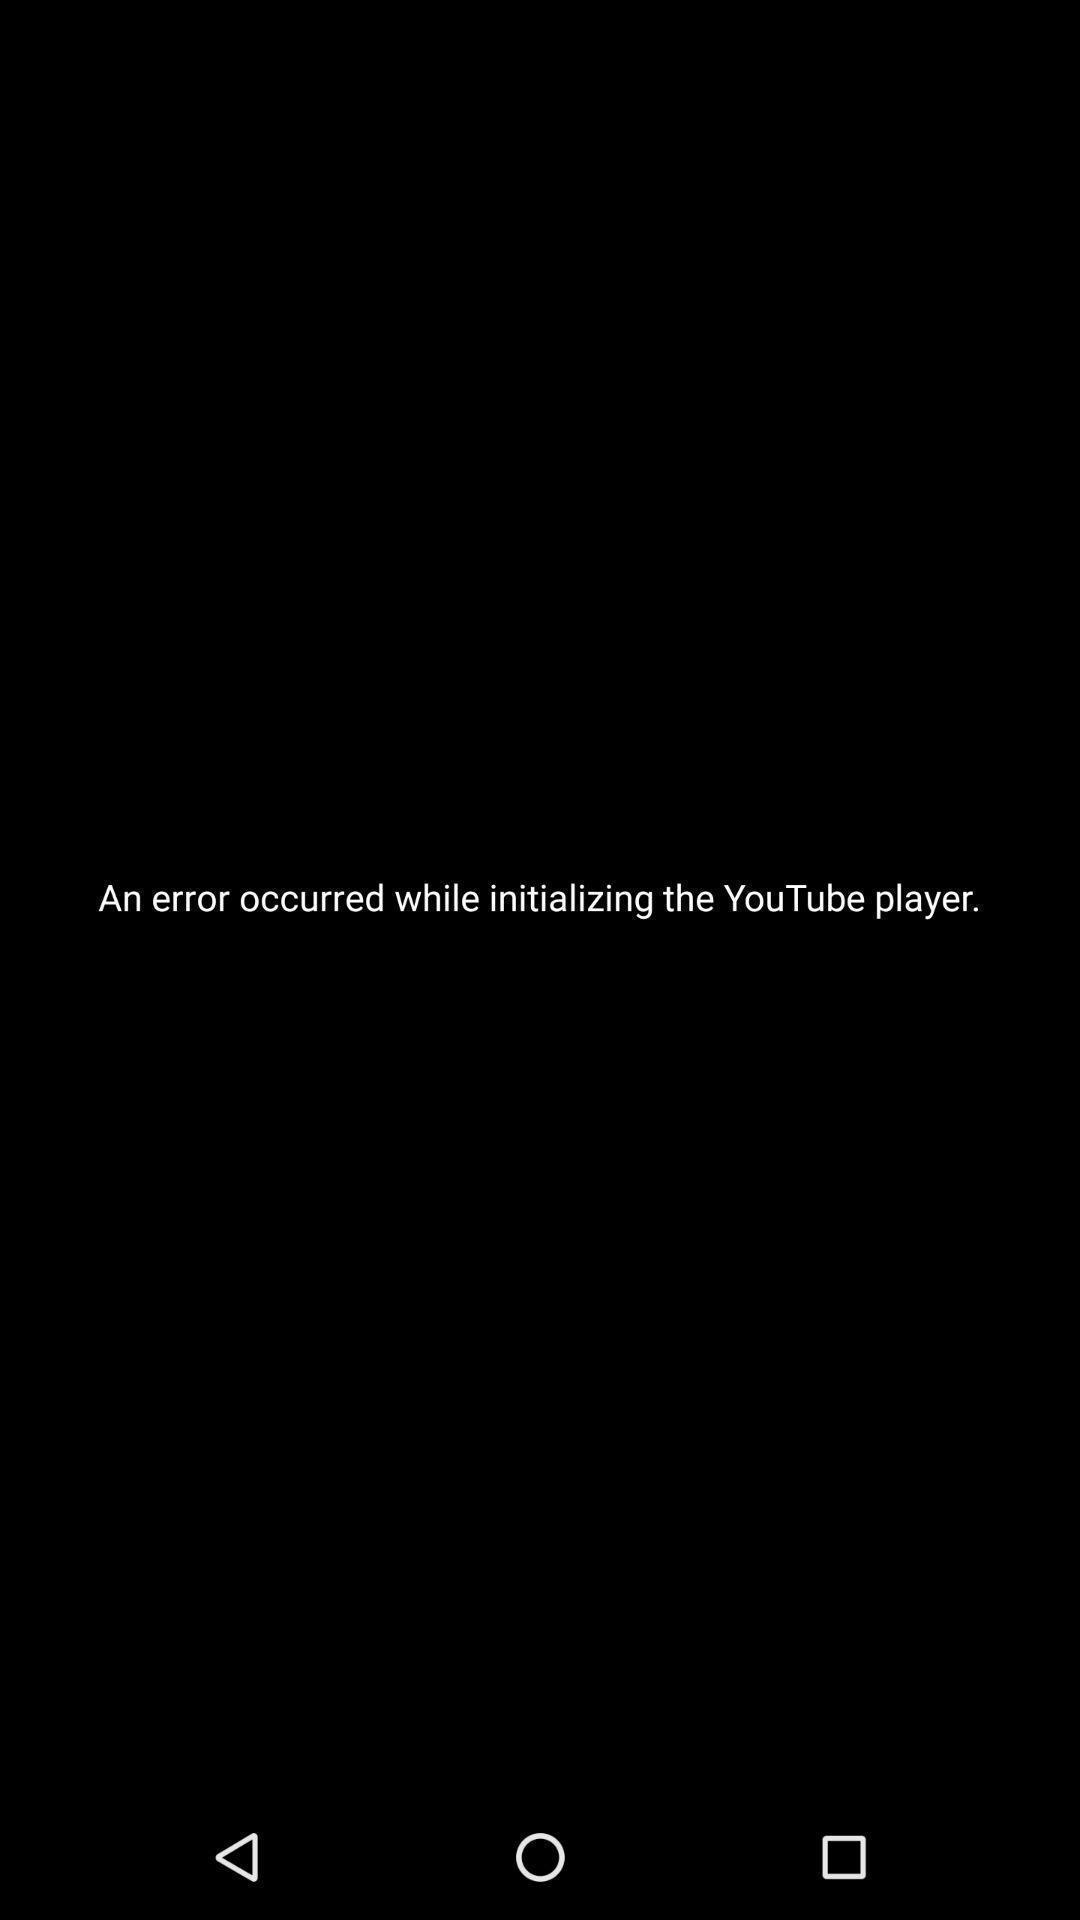Describe the key features of this screenshot. Screen shows that a network error has occurred. 